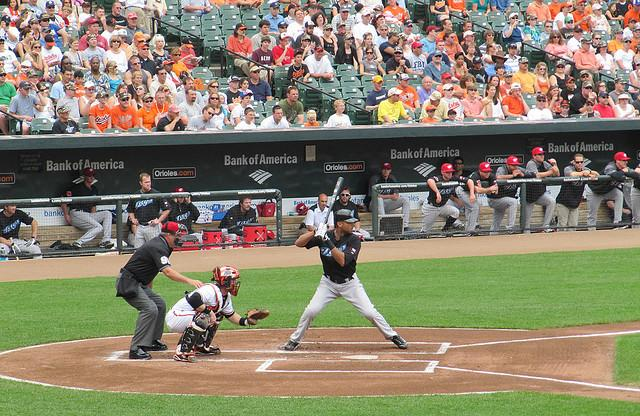What color is the umpire's helmet who is standing with his hand on the catcher's back?

Choices:
A) black
B) red
C) green
D) blue red 